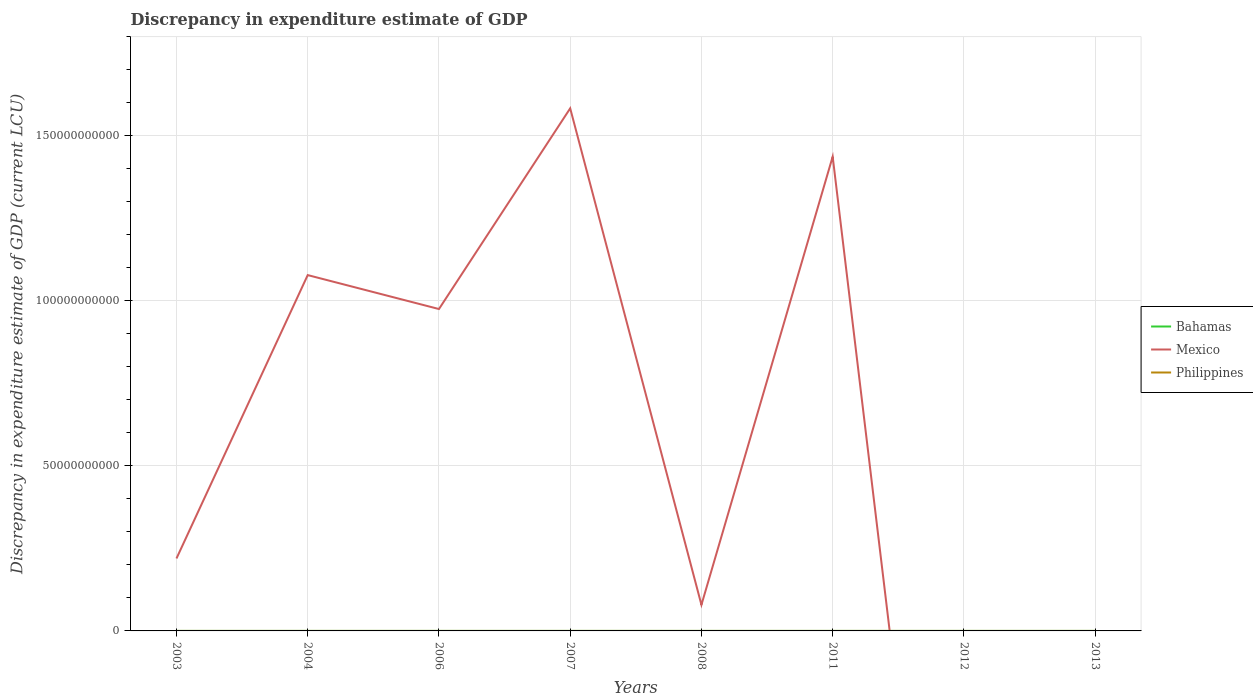How many different coloured lines are there?
Keep it short and to the point. 3. Does the line corresponding to Bahamas intersect with the line corresponding to Philippines?
Your response must be concise. Yes. Is the number of lines equal to the number of legend labels?
Your answer should be compact. No. Across all years, what is the maximum discrepancy in expenditure estimate of GDP in Philippines?
Offer a very short reply. 0. What is the total discrepancy in expenditure estimate of GDP in Mexico in the graph?
Provide a short and direct response. 1.50e+11. What is the difference between the highest and the second highest discrepancy in expenditure estimate of GDP in Mexico?
Give a very brief answer. 1.58e+11. Is the discrepancy in expenditure estimate of GDP in Mexico strictly greater than the discrepancy in expenditure estimate of GDP in Bahamas over the years?
Keep it short and to the point. No. What is the difference between two consecutive major ticks on the Y-axis?
Keep it short and to the point. 5.00e+1. Are the values on the major ticks of Y-axis written in scientific E-notation?
Your response must be concise. No. Does the graph contain any zero values?
Provide a short and direct response. Yes. What is the title of the graph?
Offer a very short reply. Discrepancy in expenditure estimate of GDP. Does "Latin America(all income levels)" appear as one of the legend labels in the graph?
Offer a very short reply. No. What is the label or title of the X-axis?
Keep it short and to the point. Years. What is the label or title of the Y-axis?
Make the answer very short. Discrepancy in expenditure estimate of GDP (current LCU). What is the Discrepancy in expenditure estimate of GDP (current LCU) of Bahamas in 2003?
Your answer should be compact. 7000. What is the Discrepancy in expenditure estimate of GDP (current LCU) in Mexico in 2003?
Offer a very short reply. 2.20e+1. What is the Discrepancy in expenditure estimate of GDP (current LCU) of Philippines in 2003?
Keep it short and to the point. 100. What is the Discrepancy in expenditure estimate of GDP (current LCU) of Bahamas in 2004?
Provide a succinct answer. 3000. What is the Discrepancy in expenditure estimate of GDP (current LCU) in Mexico in 2004?
Keep it short and to the point. 1.08e+11. What is the Discrepancy in expenditure estimate of GDP (current LCU) in Philippines in 2004?
Your answer should be compact. 0. What is the Discrepancy in expenditure estimate of GDP (current LCU) of Bahamas in 2006?
Offer a very short reply. 8000. What is the Discrepancy in expenditure estimate of GDP (current LCU) in Mexico in 2006?
Your answer should be very brief. 9.75e+1. What is the Discrepancy in expenditure estimate of GDP (current LCU) in Philippines in 2006?
Your answer should be very brief. 100. What is the Discrepancy in expenditure estimate of GDP (current LCU) in Bahamas in 2007?
Provide a succinct answer. 0. What is the Discrepancy in expenditure estimate of GDP (current LCU) of Mexico in 2007?
Your answer should be compact. 1.58e+11. What is the Discrepancy in expenditure estimate of GDP (current LCU) of Philippines in 2007?
Your response must be concise. 0. What is the Discrepancy in expenditure estimate of GDP (current LCU) of Bahamas in 2008?
Give a very brief answer. 0. What is the Discrepancy in expenditure estimate of GDP (current LCU) of Mexico in 2008?
Your response must be concise. 7.91e+09. What is the Discrepancy in expenditure estimate of GDP (current LCU) in Philippines in 2008?
Your response must be concise. 0. What is the Discrepancy in expenditure estimate of GDP (current LCU) of Bahamas in 2011?
Provide a short and direct response. 1e-6. What is the Discrepancy in expenditure estimate of GDP (current LCU) in Mexico in 2011?
Your response must be concise. 1.44e+11. What is the Discrepancy in expenditure estimate of GDP (current LCU) of Philippines in 2011?
Offer a very short reply. 0. What is the Discrepancy in expenditure estimate of GDP (current LCU) of Mexico in 2012?
Provide a succinct answer. 0. What is the Discrepancy in expenditure estimate of GDP (current LCU) in Philippines in 2012?
Your answer should be compact. 4.00e+05. What is the Discrepancy in expenditure estimate of GDP (current LCU) in Bahamas in 2013?
Make the answer very short. 0. What is the Discrepancy in expenditure estimate of GDP (current LCU) of Mexico in 2013?
Make the answer very short. 0. What is the Discrepancy in expenditure estimate of GDP (current LCU) in Philippines in 2013?
Offer a very short reply. 0. Across all years, what is the maximum Discrepancy in expenditure estimate of GDP (current LCU) in Bahamas?
Ensure brevity in your answer.  8000. Across all years, what is the maximum Discrepancy in expenditure estimate of GDP (current LCU) in Mexico?
Your answer should be compact. 1.58e+11. Across all years, what is the maximum Discrepancy in expenditure estimate of GDP (current LCU) in Philippines?
Ensure brevity in your answer.  4.00e+05. Across all years, what is the minimum Discrepancy in expenditure estimate of GDP (current LCU) in Bahamas?
Provide a short and direct response. 0. Across all years, what is the minimum Discrepancy in expenditure estimate of GDP (current LCU) of Mexico?
Make the answer very short. 0. What is the total Discrepancy in expenditure estimate of GDP (current LCU) in Bahamas in the graph?
Make the answer very short. 1.80e+04. What is the total Discrepancy in expenditure estimate of GDP (current LCU) of Mexico in the graph?
Your answer should be very brief. 5.37e+11. What is the total Discrepancy in expenditure estimate of GDP (current LCU) of Philippines in the graph?
Ensure brevity in your answer.  4.00e+05. What is the difference between the Discrepancy in expenditure estimate of GDP (current LCU) in Bahamas in 2003 and that in 2004?
Ensure brevity in your answer.  4000. What is the difference between the Discrepancy in expenditure estimate of GDP (current LCU) of Mexico in 2003 and that in 2004?
Make the answer very short. -8.59e+1. What is the difference between the Discrepancy in expenditure estimate of GDP (current LCU) of Bahamas in 2003 and that in 2006?
Provide a succinct answer. -1000. What is the difference between the Discrepancy in expenditure estimate of GDP (current LCU) of Mexico in 2003 and that in 2006?
Keep it short and to the point. -7.56e+1. What is the difference between the Discrepancy in expenditure estimate of GDP (current LCU) in Philippines in 2003 and that in 2006?
Make the answer very short. 0. What is the difference between the Discrepancy in expenditure estimate of GDP (current LCU) of Mexico in 2003 and that in 2007?
Make the answer very short. -1.36e+11. What is the difference between the Discrepancy in expenditure estimate of GDP (current LCU) in Mexico in 2003 and that in 2008?
Ensure brevity in your answer.  1.40e+1. What is the difference between the Discrepancy in expenditure estimate of GDP (current LCU) in Philippines in 2003 and that in 2008?
Provide a short and direct response. 100. What is the difference between the Discrepancy in expenditure estimate of GDP (current LCU) of Bahamas in 2003 and that in 2011?
Provide a succinct answer. 7000. What is the difference between the Discrepancy in expenditure estimate of GDP (current LCU) of Mexico in 2003 and that in 2011?
Offer a very short reply. -1.22e+11. What is the difference between the Discrepancy in expenditure estimate of GDP (current LCU) of Philippines in 2003 and that in 2012?
Your response must be concise. -4.00e+05. What is the difference between the Discrepancy in expenditure estimate of GDP (current LCU) of Bahamas in 2004 and that in 2006?
Keep it short and to the point. -5000. What is the difference between the Discrepancy in expenditure estimate of GDP (current LCU) of Mexico in 2004 and that in 2006?
Keep it short and to the point. 1.03e+1. What is the difference between the Discrepancy in expenditure estimate of GDP (current LCU) in Mexico in 2004 and that in 2007?
Your answer should be very brief. -5.05e+1. What is the difference between the Discrepancy in expenditure estimate of GDP (current LCU) of Mexico in 2004 and that in 2008?
Offer a terse response. 9.99e+1. What is the difference between the Discrepancy in expenditure estimate of GDP (current LCU) in Bahamas in 2004 and that in 2011?
Provide a succinct answer. 3000. What is the difference between the Discrepancy in expenditure estimate of GDP (current LCU) of Mexico in 2004 and that in 2011?
Offer a very short reply. -3.59e+1. What is the difference between the Discrepancy in expenditure estimate of GDP (current LCU) of Mexico in 2006 and that in 2007?
Provide a short and direct response. -6.08e+1. What is the difference between the Discrepancy in expenditure estimate of GDP (current LCU) in Mexico in 2006 and that in 2008?
Offer a terse response. 8.96e+1. What is the difference between the Discrepancy in expenditure estimate of GDP (current LCU) in Philippines in 2006 and that in 2008?
Ensure brevity in your answer.  100. What is the difference between the Discrepancy in expenditure estimate of GDP (current LCU) in Bahamas in 2006 and that in 2011?
Provide a succinct answer. 8000. What is the difference between the Discrepancy in expenditure estimate of GDP (current LCU) of Mexico in 2006 and that in 2011?
Make the answer very short. -4.62e+1. What is the difference between the Discrepancy in expenditure estimate of GDP (current LCU) in Philippines in 2006 and that in 2012?
Your answer should be compact. -4.00e+05. What is the difference between the Discrepancy in expenditure estimate of GDP (current LCU) of Mexico in 2007 and that in 2008?
Keep it short and to the point. 1.50e+11. What is the difference between the Discrepancy in expenditure estimate of GDP (current LCU) in Mexico in 2007 and that in 2011?
Provide a succinct answer. 1.46e+1. What is the difference between the Discrepancy in expenditure estimate of GDP (current LCU) of Mexico in 2008 and that in 2011?
Ensure brevity in your answer.  -1.36e+11. What is the difference between the Discrepancy in expenditure estimate of GDP (current LCU) in Philippines in 2008 and that in 2012?
Offer a terse response. -4.00e+05. What is the difference between the Discrepancy in expenditure estimate of GDP (current LCU) of Bahamas in 2003 and the Discrepancy in expenditure estimate of GDP (current LCU) of Mexico in 2004?
Your answer should be compact. -1.08e+11. What is the difference between the Discrepancy in expenditure estimate of GDP (current LCU) of Bahamas in 2003 and the Discrepancy in expenditure estimate of GDP (current LCU) of Mexico in 2006?
Keep it short and to the point. -9.75e+1. What is the difference between the Discrepancy in expenditure estimate of GDP (current LCU) of Bahamas in 2003 and the Discrepancy in expenditure estimate of GDP (current LCU) of Philippines in 2006?
Keep it short and to the point. 6900. What is the difference between the Discrepancy in expenditure estimate of GDP (current LCU) of Mexico in 2003 and the Discrepancy in expenditure estimate of GDP (current LCU) of Philippines in 2006?
Provide a short and direct response. 2.20e+1. What is the difference between the Discrepancy in expenditure estimate of GDP (current LCU) of Bahamas in 2003 and the Discrepancy in expenditure estimate of GDP (current LCU) of Mexico in 2007?
Your answer should be very brief. -1.58e+11. What is the difference between the Discrepancy in expenditure estimate of GDP (current LCU) in Bahamas in 2003 and the Discrepancy in expenditure estimate of GDP (current LCU) in Mexico in 2008?
Offer a very short reply. -7.91e+09. What is the difference between the Discrepancy in expenditure estimate of GDP (current LCU) in Bahamas in 2003 and the Discrepancy in expenditure estimate of GDP (current LCU) in Philippines in 2008?
Ensure brevity in your answer.  7000. What is the difference between the Discrepancy in expenditure estimate of GDP (current LCU) in Mexico in 2003 and the Discrepancy in expenditure estimate of GDP (current LCU) in Philippines in 2008?
Make the answer very short. 2.20e+1. What is the difference between the Discrepancy in expenditure estimate of GDP (current LCU) of Bahamas in 2003 and the Discrepancy in expenditure estimate of GDP (current LCU) of Mexico in 2011?
Provide a succinct answer. -1.44e+11. What is the difference between the Discrepancy in expenditure estimate of GDP (current LCU) in Bahamas in 2003 and the Discrepancy in expenditure estimate of GDP (current LCU) in Philippines in 2012?
Your response must be concise. -3.93e+05. What is the difference between the Discrepancy in expenditure estimate of GDP (current LCU) in Mexico in 2003 and the Discrepancy in expenditure estimate of GDP (current LCU) in Philippines in 2012?
Offer a very short reply. 2.20e+1. What is the difference between the Discrepancy in expenditure estimate of GDP (current LCU) in Bahamas in 2004 and the Discrepancy in expenditure estimate of GDP (current LCU) in Mexico in 2006?
Your response must be concise. -9.75e+1. What is the difference between the Discrepancy in expenditure estimate of GDP (current LCU) of Bahamas in 2004 and the Discrepancy in expenditure estimate of GDP (current LCU) of Philippines in 2006?
Make the answer very short. 2900. What is the difference between the Discrepancy in expenditure estimate of GDP (current LCU) in Mexico in 2004 and the Discrepancy in expenditure estimate of GDP (current LCU) in Philippines in 2006?
Your answer should be compact. 1.08e+11. What is the difference between the Discrepancy in expenditure estimate of GDP (current LCU) in Bahamas in 2004 and the Discrepancy in expenditure estimate of GDP (current LCU) in Mexico in 2007?
Keep it short and to the point. -1.58e+11. What is the difference between the Discrepancy in expenditure estimate of GDP (current LCU) in Bahamas in 2004 and the Discrepancy in expenditure estimate of GDP (current LCU) in Mexico in 2008?
Provide a succinct answer. -7.91e+09. What is the difference between the Discrepancy in expenditure estimate of GDP (current LCU) in Bahamas in 2004 and the Discrepancy in expenditure estimate of GDP (current LCU) in Philippines in 2008?
Give a very brief answer. 3000. What is the difference between the Discrepancy in expenditure estimate of GDP (current LCU) of Mexico in 2004 and the Discrepancy in expenditure estimate of GDP (current LCU) of Philippines in 2008?
Offer a terse response. 1.08e+11. What is the difference between the Discrepancy in expenditure estimate of GDP (current LCU) in Bahamas in 2004 and the Discrepancy in expenditure estimate of GDP (current LCU) in Mexico in 2011?
Ensure brevity in your answer.  -1.44e+11. What is the difference between the Discrepancy in expenditure estimate of GDP (current LCU) of Bahamas in 2004 and the Discrepancy in expenditure estimate of GDP (current LCU) of Philippines in 2012?
Provide a succinct answer. -3.97e+05. What is the difference between the Discrepancy in expenditure estimate of GDP (current LCU) in Mexico in 2004 and the Discrepancy in expenditure estimate of GDP (current LCU) in Philippines in 2012?
Provide a short and direct response. 1.08e+11. What is the difference between the Discrepancy in expenditure estimate of GDP (current LCU) of Bahamas in 2006 and the Discrepancy in expenditure estimate of GDP (current LCU) of Mexico in 2007?
Your response must be concise. -1.58e+11. What is the difference between the Discrepancy in expenditure estimate of GDP (current LCU) in Bahamas in 2006 and the Discrepancy in expenditure estimate of GDP (current LCU) in Mexico in 2008?
Provide a succinct answer. -7.91e+09. What is the difference between the Discrepancy in expenditure estimate of GDP (current LCU) in Bahamas in 2006 and the Discrepancy in expenditure estimate of GDP (current LCU) in Philippines in 2008?
Offer a terse response. 8000. What is the difference between the Discrepancy in expenditure estimate of GDP (current LCU) in Mexico in 2006 and the Discrepancy in expenditure estimate of GDP (current LCU) in Philippines in 2008?
Give a very brief answer. 9.75e+1. What is the difference between the Discrepancy in expenditure estimate of GDP (current LCU) in Bahamas in 2006 and the Discrepancy in expenditure estimate of GDP (current LCU) in Mexico in 2011?
Provide a short and direct response. -1.44e+11. What is the difference between the Discrepancy in expenditure estimate of GDP (current LCU) of Bahamas in 2006 and the Discrepancy in expenditure estimate of GDP (current LCU) of Philippines in 2012?
Provide a succinct answer. -3.92e+05. What is the difference between the Discrepancy in expenditure estimate of GDP (current LCU) of Mexico in 2006 and the Discrepancy in expenditure estimate of GDP (current LCU) of Philippines in 2012?
Give a very brief answer. 9.75e+1. What is the difference between the Discrepancy in expenditure estimate of GDP (current LCU) of Mexico in 2007 and the Discrepancy in expenditure estimate of GDP (current LCU) of Philippines in 2008?
Ensure brevity in your answer.  1.58e+11. What is the difference between the Discrepancy in expenditure estimate of GDP (current LCU) of Mexico in 2007 and the Discrepancy in expenditure estimate of GDP (current LCU) of Philippines in 2012?
Provide a short and direct response. 1.58e+11. What is the difference between the Discrepancy in expenditure estimate of GDP (current LCU) of Mexico in 2008 and the Discrepancy in expenditure estimate of GDP (current LCU) of Philippines in 2012?
Give a very brief answer. 7.91e+09. What is the difference between the Discrepancy in expenditure estimate of GDP (current LCU) in Bahamas in 2011 and the Discrepancy in expenditure estimate of GDP (current LCU) in Philippines in 2012?
Your answer should be very brief. -4.00e+05. What is the difference between the Discrepancy in expenditure estimate of GDP (current LCU) of Mexico in 2011 and the Discrepancy in expenditure estimate of GDP (current LCU) of Philippines in 2012?
Offer a terse response. 1.44e+11. What is the average Discrepancy in expenditure estimate of GDP (current LCU) in Bahamas per year?
Offer a terse response. 2250. What is the average Discrepancy in expenditure estimate of GDP (current LCU) of Mexico per year?
Your answer should be compact. 6.72e+1. What is the average Discrepancy in expenditure estimate of GDP (current LCU) in Philippines per year?
Your answer should be very brief. 5.00e+04. In the year 2003, what is the difference between the Discrepancy in expenditure estimate of GDP (current LCU) of Bahamas and Discrepancy in expenditure estimate of GDP (current LCU) of Mexico?
Ensure brevity in your answer.  -2.20e+1. In the year 2003, what is the difference between the Discrepancy in expenditure estimate of GDP (current LCU) in Bahamas and Discrepancy in expenditure estimate of GDP (current LCU) in Philippines?
Offer a terse response. 6900. In the year 2003, what is the difference between the Discrepancy in expenditure estimate of GDP (current LCU) in Mexico and Discrepancy in expenditure estimate of GDP (current LCU) in Philippines?
Your answer should be very brief. 2.20e+1. In the year 2004, what is the difference between the Discrepancy in expenditure estimate of GDP (current LCU) in Bahamas and Discrepancy in expenditure estimate of GDP (current LCU) in Mexico?
Offer a terse response. -1.08e+11. In the year 2006, what is the difference between the Discrepancy in expenditure estimate of GDP (current LCU) in Bahamas and Discrepancy in expenditure estimate of GDP (current LCU) in Mexico?
Your answer should be very brief. -9.75e+1. In the year 2006, what is the difference between the Discrepancy in expenditure estimate of GDP (current LCU) in Bahamas and Discrepancy in expenditure estimate of GDP (current LCU) in Philippines?
Provide a succinct answer. 7900. In the year 2006, what is the difference between the Discrepancy in expenditure estimate of GDP (current LCU) of Mexico and Discrepancy in expenditure estimate of GDP (current LCU) of Philippines?
Your response must be concise. 9.75e+1. In the year 2008, what is the difference between the Discrepancy in expenditure estimate of GDP (current LCU) of Mexico and Discrepancy in expenditure estimate of GDP (current LCU) of Philippines?
Your response must be concise. 7.91e+09. In the year 2011, what is the difference between the Discrepancy in expenditure estimate of GDP (current LCU) of Bahamas and Discrepancy in expenditure estimate of GDP (current LCU) of Mexico?
Your answer should be compact. -1.44e+11. What is the ratio of the Discrepancy in expenditure estimate of GDP (current LCU) in Bahamas in 2003 to that in 2004?
Keep it short and to the point. 2.33. What is the ratio of the Discrepancy in expenditure estimate of GDP (current LCU) of Mexico in 2003 to that in 2004?
Offer a terse response. 0.2. What is the ratio of the Discrepancy in expenditure estimate of GDP (current LCU) in Bahamas in 2003 to that in 2006?
Keep it short and to the point. 0.88. What is the ratio of the Discrepancy in expenditure estimate of GDP (current LCU) in Mexico in 2003 to that in 2006?
Provide a succinct answer. 0.23. What is the ratio of the Discrepancy in expenditure estimate of GDP (current LCU) of Mexico in 2003 to that in 2007?
Your answer should be compact. 0.14. What is the ratio of the Discrepancy in expenditure estimate of GDP (current LCU) of Mexico in 2003 to that in 2008?
Your answer should be very brief. 2.78. What is the ratio of the Discrepancy in expenditure estimate of GDP (current LCU) in Philippines in 2003 to that in 2008?
Offer a terse response. 1.00e+05. What is the ratio of the Discrepancy in expenditure estimate of GDP (current LCU) in Bahamas in 2003 to that in 2011?
Offer a very short reply. 7.00e+09. What is the ratio of the Discrepancy in expenditure estimate of GDP (current LCU) of Mexico in 2003 to that in 2011?
Offer a very short reply. 0.15. What is the ratio of the Discrepancy in expenditure estimate of GDP (current LCU) of Bahamas in 2004 to that in 2006?
Make the answer very short. 0.38. What is the ratio of the Discrepancy in expenditure estimate of GDP (current LCU) of Mexico in 2004 to that in 2006?
Your answer should be compact. 1.11. What is the ratio of the Discrepancy in expenditure estimate of GDP (current LCU) of Mexico in 2004 to that in 2007?
Provide a succinct answer. 0.68. What is the ratio of the Discrepancy in expenditure estimate of GDP (current LCU) of Mexico in 2004 to that in 2008?
Your response must be concise. 13.63. What is the ratio of the Discrepancy in expenditure estimate of GDP (current LCU) of Bahamas in 2004 to that in 2011?
Your answer should be very brief. 3.00e+09. What is the ratio of the Discrepancy in expenditure estimate of GDP (current LCU) in Mexico in 2004 to that in 2011?
Your answer should be compact. 0.75. What is the ratio of the Discrepancy in expenditure estimate of GDP (current LCU) of Mexico in 2006 to that in 2007?
Your response must be concise. 0.62. What is the ratio of the Discrepancy in expenditure estimate of GDP (current LCU) in Mexico in 2006 to that in 2008?
Your answer should be compact. 12.33. What is the ratio of the Discrepancy in expenditure estimate of GDP (current LCU) of Philippines in 2006 to that in 2008?
Your response must be concise. 1.00e+05. What is the ratio of the Discrepancy in expenditure estimate of GDP (current LCU) of Bahamas in 2006 to that in 2011?
Provide a succinct answer. 8.00e+09. What is the ratio of the Discrepancy in expenditure estimate of GDP (current LCU) of Mexico in 2006 to that in 2011?
Provide a succinct answer. 0.68. What is the ratio of the Discrepancy in expenditure estimate of GDP (current LCU) of Mexico in 2007 to that in 2008?
Make the answer very short. 20.02. What is the ratio of the Discrepancy in expenditure estimate of GDP (current LCU) of Mexico in 2007 to that in 2011?
Give a very brief answer. 1.1. What is the ratio of the Discrepancy in expenditure estimate of GDP (current LCU) in Mexico in 2008 to that in 2011?
Your answer should be compact. 0.06. What is the ratio of the Discrepancy in expenditure estimate of GDP (current LCU) of Philippines in 2008 to that in 2012?
Keep it short and to the point. 0. What is the difference between the highest and the second highest Discrepancy in expenditure estimate of GDP (current LCU) in Bahamas?
Make the answer very short. 1000. What is the difference between the highest and the second highest Discrepancy in expenditure estimate of GDP (current LCU) of Mexico?
Give a very brief answer. 1.46e+1. What is the difference between the highest and the second highest Discrepancy in expenditure estimate of GDP (current LCU) in Philippines?
Give a very brief answer. 4.00e+05. What is the difference between the highest and the lowest Discrepancy in expenditure estimate of GDP (current LCU) of Bahamas?
Your answer should be very brief. 8000. What is the difference between the highest and the lowest Discrepancy in expenditure estimate of GDP (current LCU) of Mexico?
Give a very brief answer. 1.58e+11. What is the difference between the highest and the lowest Discrepancy in expenditure estimate of GDP (current LCU) in Philippines?
Provide a succinct answer. 4.00e+05. 